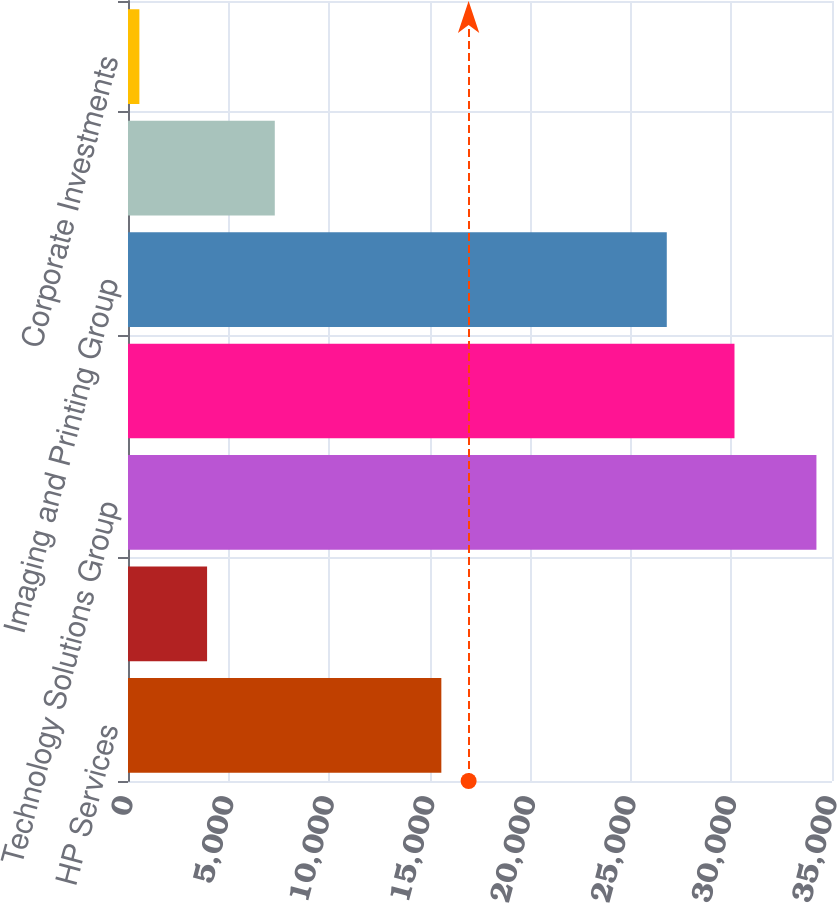Convert chart to OTSL. <chart><loc_0><loc_0><loc_500><loc_500><bar_chart><fcel>HP Services<fcel>HP Software<fcel>Technology Solutions Group<fcel>Personal Systems Group<fcel>Imaging and Printing Group<fcel>HP Financial Services<fcel>Corporate Investments<nl><fcel>15578<fcel>3932<fcel>34226<fcel>30152<fcel>26786<fcel>7298<fcel>566<nl></chart> 